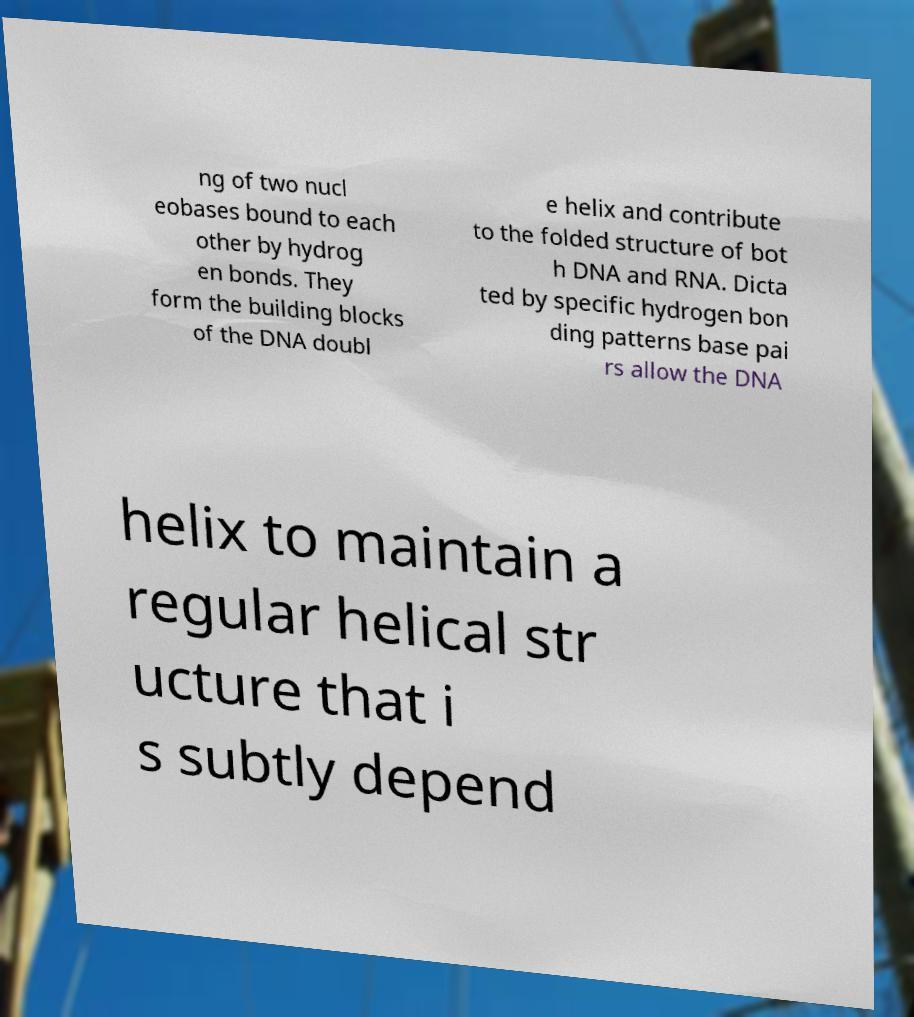Could you extract and type out the text from this image? ng of two nucl eobases bound to each other by hydrog en bonds. They form the building blocks of the DNA doubl e helix and contribute to the folded structure of bot h DNA and RNA. Dicta ted by specific hydrogen bon ding patterns base pai rs allow the DNA helix to maintain a regular helical str ucture that i s subtly depend 